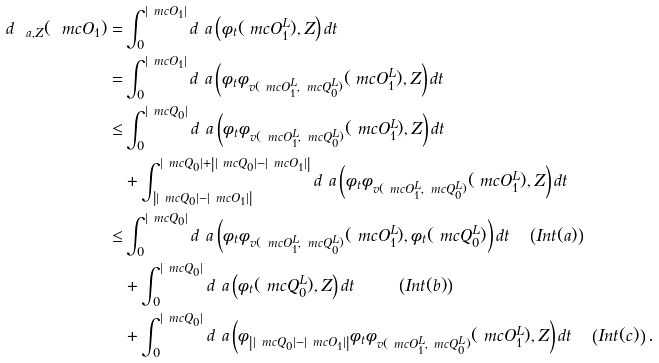<formula> <loc_0><loc_0><loc_500><loc_500>d _ { \ a , Z } ( \ m c O _ { 1 } ) = & \int _ { 0 } ^ { | \ m c O _ { 1 } | } d ^ { \ } a \left ( \phi _ { t } ( \ m c O _ { 1 } ^ { L } ) , Z \right ) d t \\ = & \int _ { 0 } ^ { | \ m c O _ { 1 } | } d ^ { \ } a \left ( \phi _ { t } \phi _ { v ( \ m c O ^ { L } _ { 1 } , \ m c Q ^ { L } _ { 0 } ) } ( \ m c O _ { 1 } ^ { L } ) , Z \right ) d t \\ \leq & \int _ { 0 } ^ { | \ m c Q _ { 0 } | } d ^ { \ } a \left ( \phi _ { t } \phi _ { v ( \ m c O ^ { L } _ { 1 } , \ m c Q ^ { L } _ { 0 } ) } ( \ m c O _ { 1 } ^ { L } ) , Z \right ) d t \\ & + \int _ { \left | | \ m c Q _ { 0 } | - | \ m c O _ { 1 } | \right | } ^ { | \ m c Q _ { 0 } | + \left | | \ m c Q _ { 0 } | - | \ m c O _ { 1 } | \right | } d ^ { \ } a \left ( \phi _ { t } \phi _ { v ( \ m c O ^ { L } _ { 1 } , \ m c Q ^ { L } _ { 0 } ) } ( \ m c O _ { 1 } ^ { L } ) , Z \right ) d t \\ \leq & \int _ { 0 } ^ { | \ m c Q _ { 0 } | } d ^ { \ } a \left ( \phi _ { t } \phi _ { v ( \ m c O ^ { L } _ { 1 } , \ m c Q ^ { L } _ { 0 } ) } ( \ m c O _ { 1 } ^ { L } ) , \phi _ { t } ( \ m c Q _ { 0 } ^ { L } ) \right ) d t \quad \left ( I n t ( a ) \right ) \\ & + \int _ { 0 } ^ { | \ m c Q _ { 0 } | } d ^ { \ } a \left ( \phi _ { t } ( \ m c Q ^ { L } _ { 0 } ) , Z \right ) d t \quad \ \quad \left ( I n t ( b ) \right ) \\ & + \int _ { 0 } ^ { | \ m c Q _ { 0 } | } d ^ { \ } a \left ( \phi _ { \left | | \ m c Q _ { 0 } | - | \ m c O _ { 1 } | \right | } \phi _ { t } \phi _ { v ( \ m c O ^ { L } _ { 1 } , \ m c Q ^ { L } _ { 0 } ) } ( \ m c O _ { 1 } ^ { L } ) , Z \right ) d t \quad \left ( I n t ( c ) \right ) .</formula> 